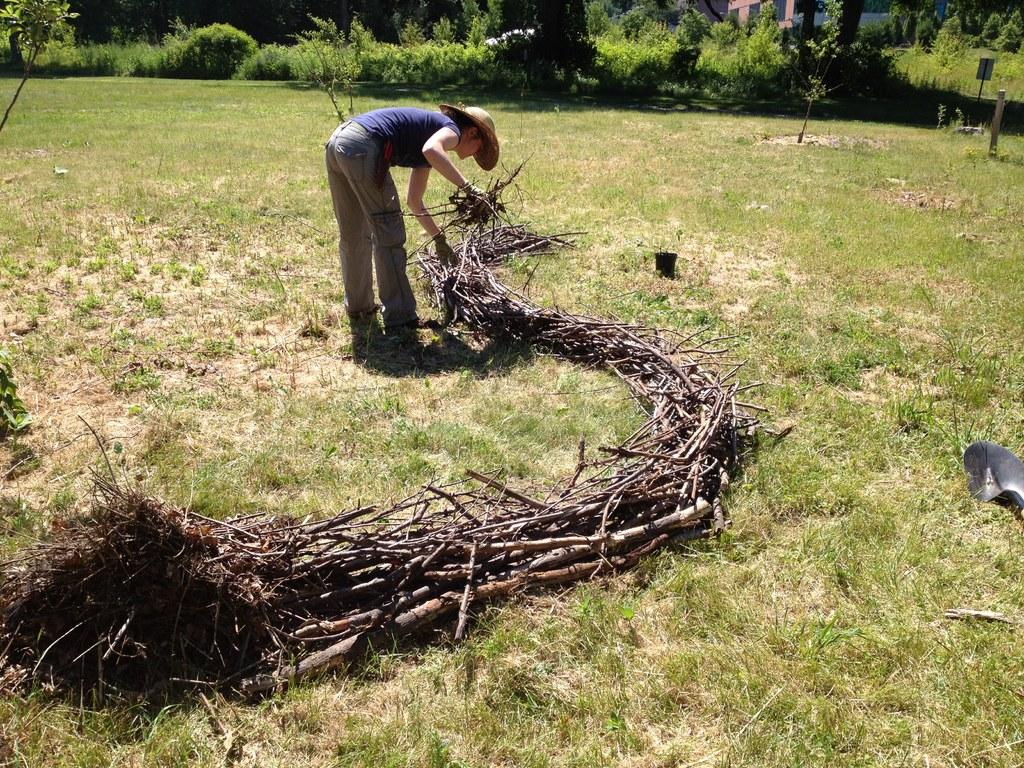What is the person in the image wearing on their head? The person in the image is wearing a hat. What type of natural elements can be seen in the image? Twigs, grass, plants, and trees are visible in the image. What object is present for growing plants? There is a flower pot in the image. What type of insect can be seen crawling on the oranges in the image? There are no oranges or insects present in the image. What color is the flower pot in the image? The provided facts do not mention the color of the flower pot, so we cannot determine its color from the image. 